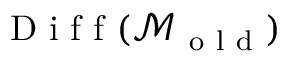<formula> <loc_0><loc_0><loc_500><loc_500>D i f f ( \mathcal { M } _ { o l d } )</formula> 